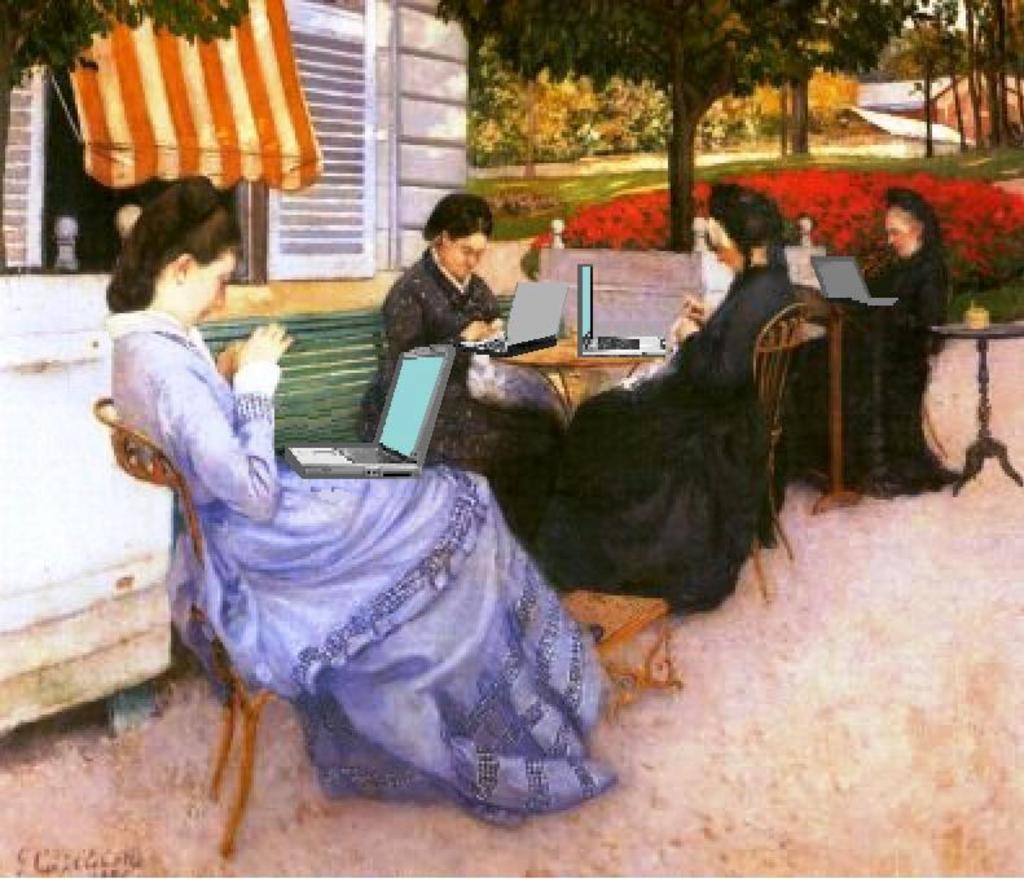In one or two sentences, can you explain what this image depicts? In this picture we can observe a painting. In this painting there are some women sitting in the chairs. We can observe laptops in front of every woman. On the left side there is a building. In the background there are trees and plants. 